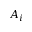<formula> <loc_0><loc_0><loc_500><loc_500>A _ { i }</formula> 